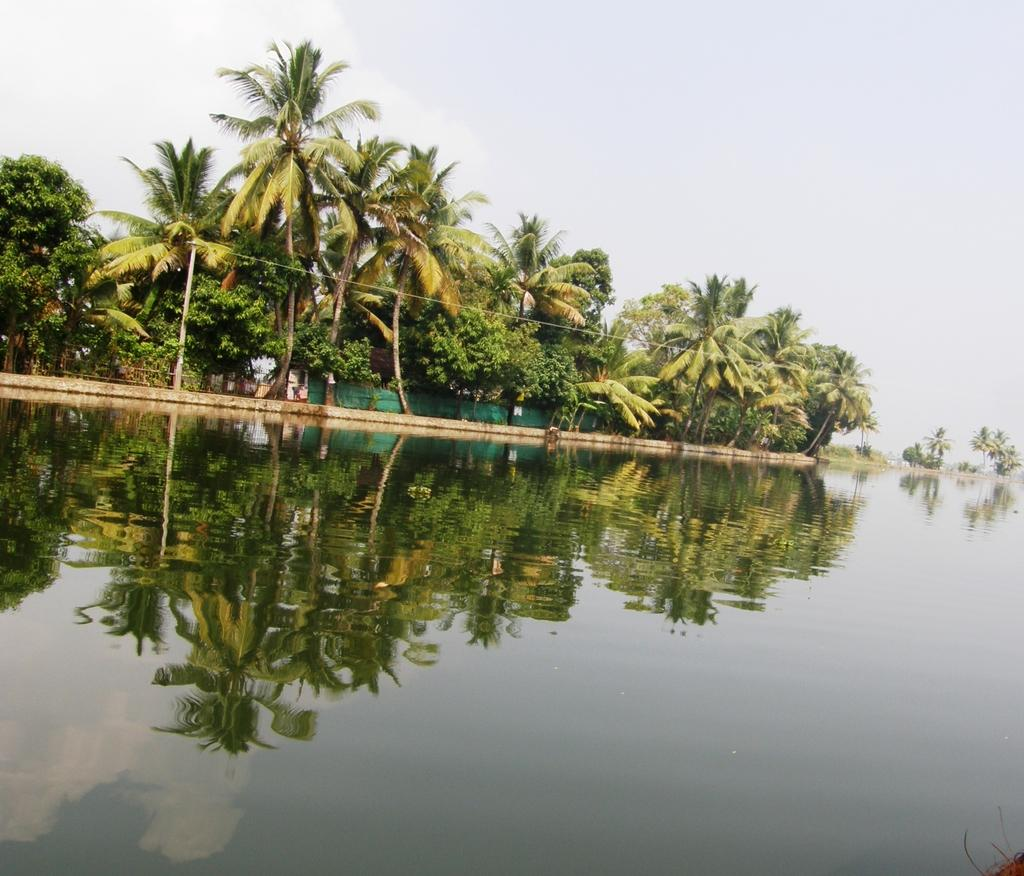What is at the bottom of the image? There is water at the bottom of the image. What can be seen reflected on the water? There is a reflection of trees on the water. What type of vegetation is behind the water? There are trees behind the water. What is visible at the top of the image? The sky is visible at the top of the image. Can you see a donkey smashing through the trees in the image? No, there is no donkey or any smashing activity depicted in the image. 